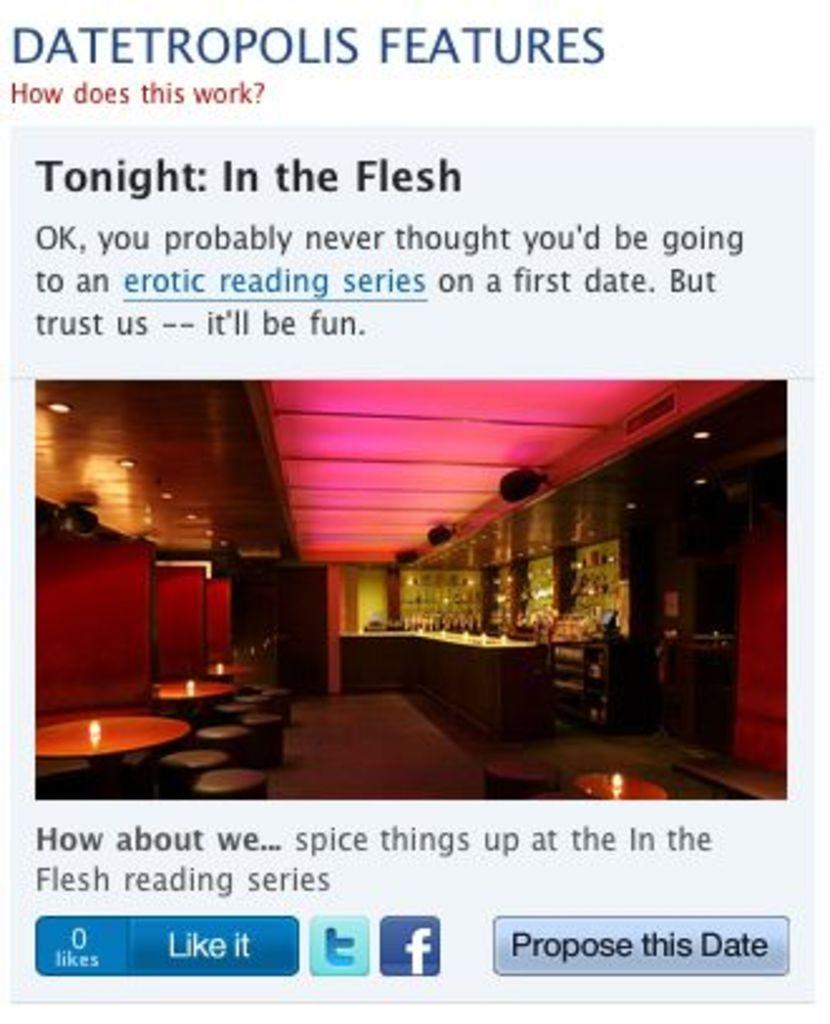Could you give a brief overview of what you see in this image? In the middle of the image we can see electric lights, candles, objects arranged in the cupboards and seating stools. At the top and bottom of the image we can see text. 